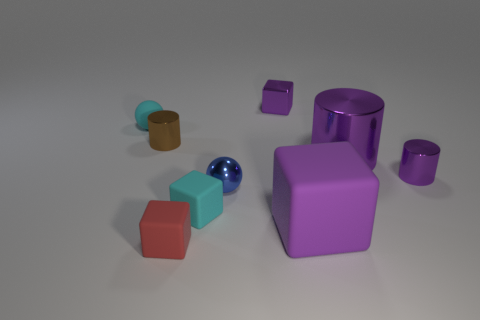Subtract 1 cylinders. How many cylinders are left? 2 Subtract all green blocks. Subtract all cyan cylinders. How many blocks are left? 4 Add 1 big purple balls. How many objects exist? 10 Subtract all spheres. How many objects are left? 7 Add 1 large blocks. How many large blocks exist? 2 Subtract 0 gray balls. How many objects are left? 9 Subtract all large purple matte things. Subtract all small blue spheres. How many objects are left? 7 Add 1 tiny matte things. How many tiny matte things are left? 4 